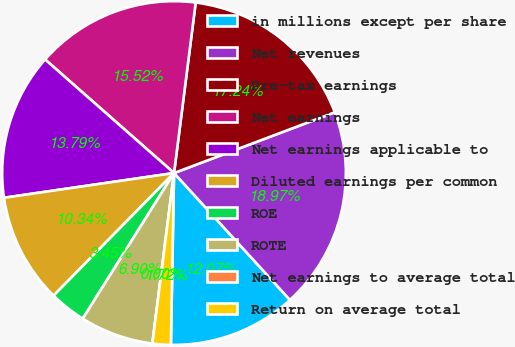Convert chart to OTSL. <chart><loc_0><loc_0><loc_500><loc_500><pie_chart><fcel>in millions except per share<fcel>Net revenues<fcel>Pre-tax earnings<fcel>Net earnings<fcel>Net earnings applicable to<fcel>Diluted earnings per common<fcel>ROE<fcel>ROTE<fcel>Net earnings to average total<fcel>Return on average total<nl><fcel>12.07%<fcel>18.97%<fcel>17.24%<fcel>15.52%<fcel>13.79%<fcel>10.34%<fcel>3.45%<fcel>6.9%<fcel>0.0%<fcel>1.72%<nl></chart> 